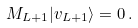Convert formula to latex. <formula><loc_0><loc_0><loc_500><loc_500>M _ { L + 1 } | v _ { L + 1 } \rangle = 0 \, .</formula> 